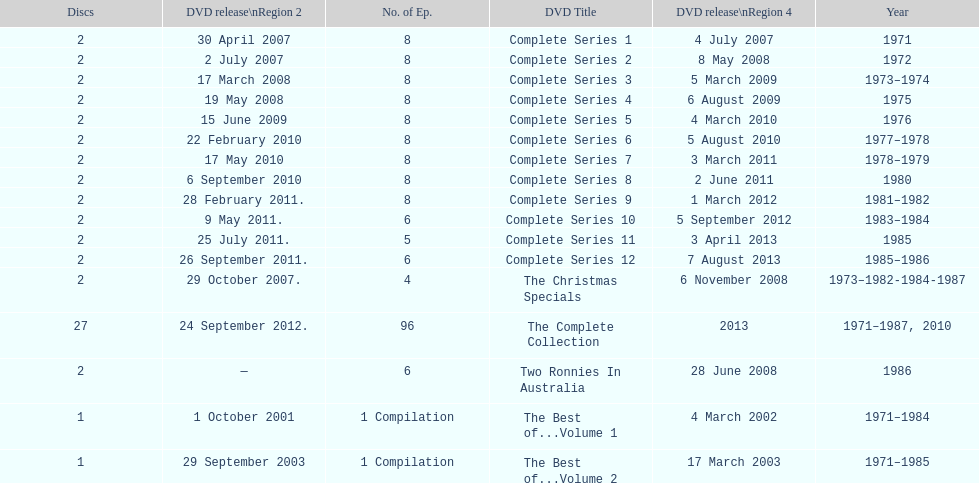Dvd shorter than 5 episodes The Christmas Specials. 